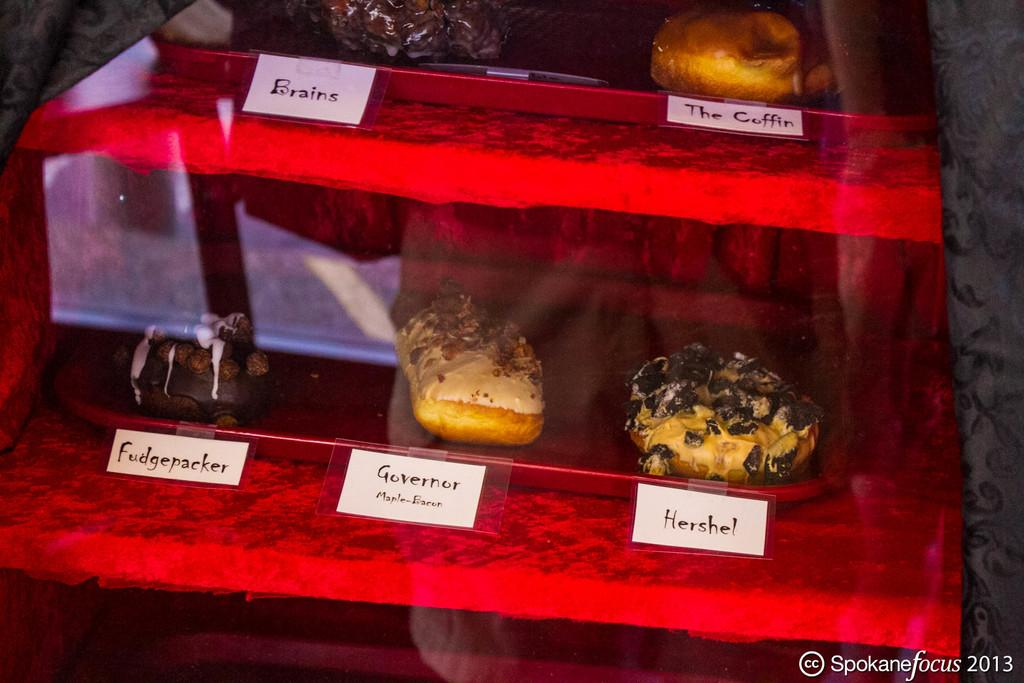Provide a one-sentence caption for the provided image. A case of a variety of dounuts with a name tags below the doughnuts including, Brains, The Coffin, Frankenstein, Governor, and Hershel. 